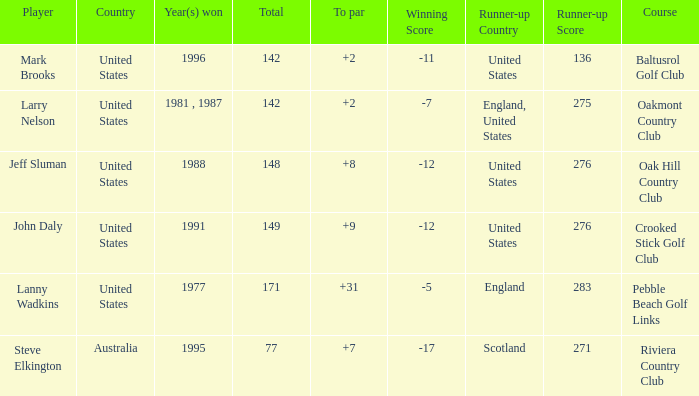Name the Total of australia and a To par smaller than 7? None. 